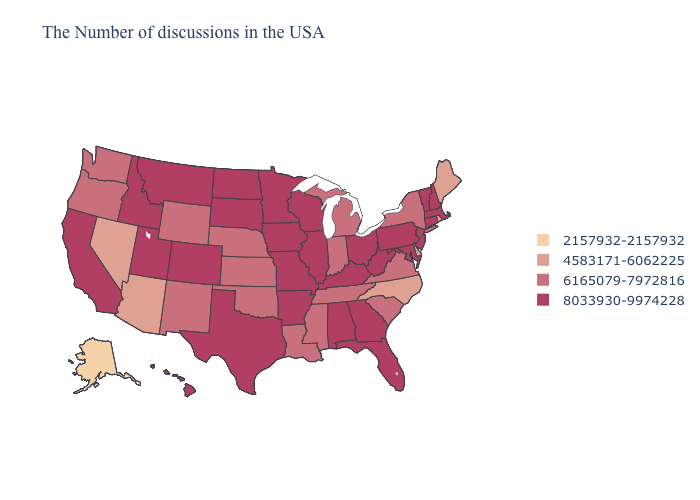Is the legend a continuous bar?
Be succinct. No. What is the highest value in the USA?
Short answer required. 8033930-9974228. What is the value of Iowa?
Short answer required. 8033930-9974228. Does New Hampshire have the highest value in the Northeast?
Quick response, please. Yes. Name the states that have a value in the range 6165079-7972816?
Short answer required. New York, Virginia, South Carolina, Michigan, Indiana, Tennessee, Mississippi, Louisiana, Kansas, Nebraska, Oklahoma, Wyoming, New Mexico, Washington, Oregon. Does the first symbol in the legend represent the smallest category?
Short answer required. Yes. Name the states that have a value in the range 6165079-7972816?
Give a very brief answer. New York, Virginia, South Carolina, Michigan, Indiana, Tennessee, Mississippi, Louisiana, Kansas, Nebraska, Oklahoma, Wyoming, New Mexico, Washington, Oregon. What is the highest value in the West ?
Short answer required. 8033930-9974228. Name the states that have a value in the range 4583171-6062225?
Concise answer only. Maine, Rhode Island, Delaware, North Carolina, Arizona, Nevada. Is the legend a continuous bar?
Concise answer only. No. Among the states that border Ohio , which have the lowest value?
Concise answer only. Michigan, Indiana. Which states have the lowest value in the MidWest?
Be succinct. Michigan, Indiana, Kansas, Nebraska. What is the lowest value in the USA?
Concise answer only. 2157932-2157932. Name the states that have a value in the range 4583171-6062225?
Keep it brief. Maine, Rhode Island, Delaware, North Carolina, Arizona, Nevada. What is the value of Maine?
Concise answer only. 4583171-6062225. 